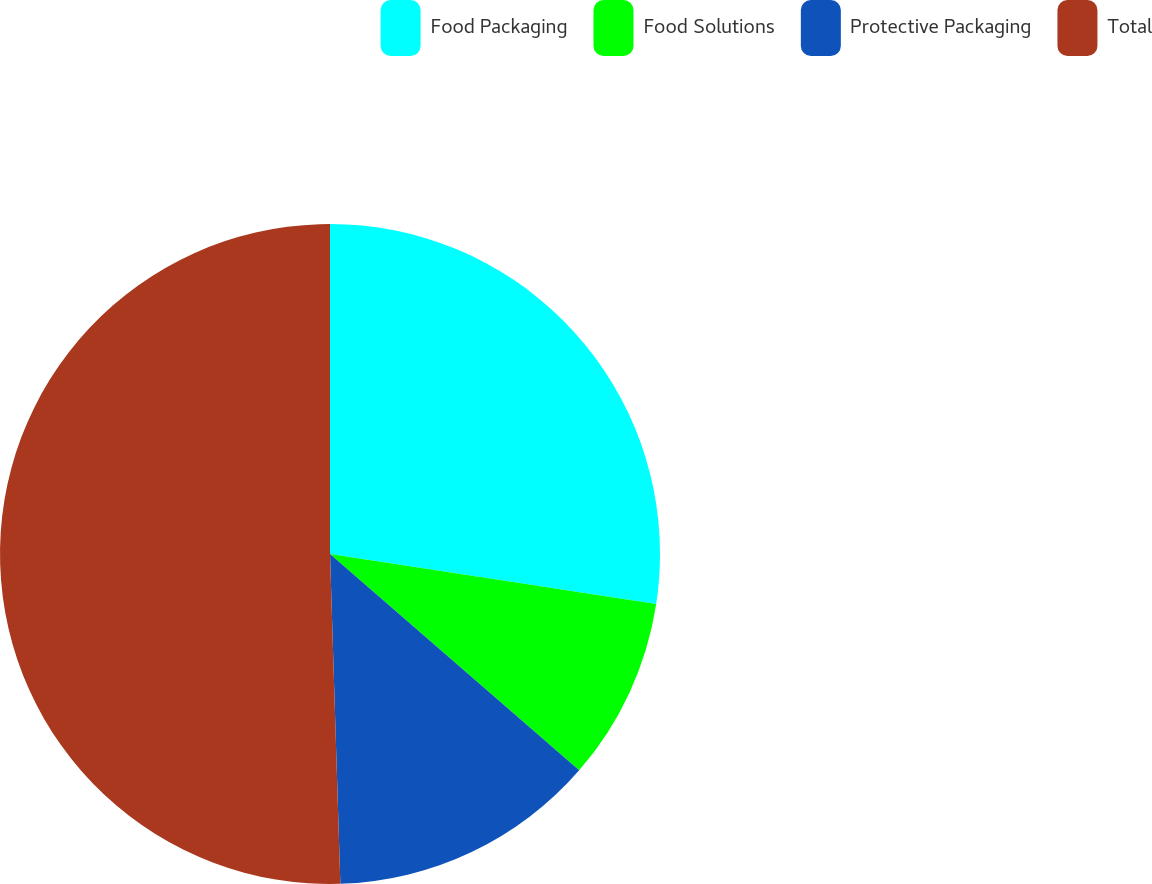Convert chart to OTSL. <chart><loc_0><loc_0><loc_500><loc_500><pie_chart><fcel>Food Packaging<fcel>Food Solutions<fcel>Protective Packaging<fcel>Total<nl><fcel>27.42%<fcel>8.96%<fcel>13.12%<fcel>50.5%<nl></chart> 